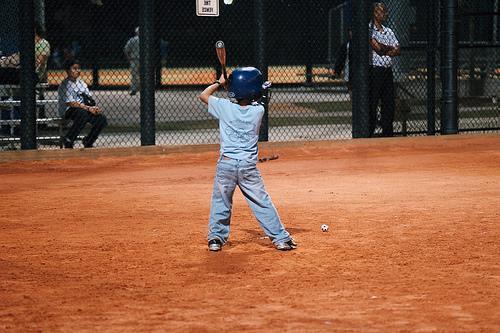How many bats are there?
Give a very brief answer. 1. 